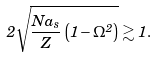<formula> <loc_0><loc_0><loc_500><loc_500>2 \sqrt { \frac { N a _ { s } } { Z } \left ( 1 - \Omega ^ { 2 } \right ) } \gtrsim 1 .</formula> 